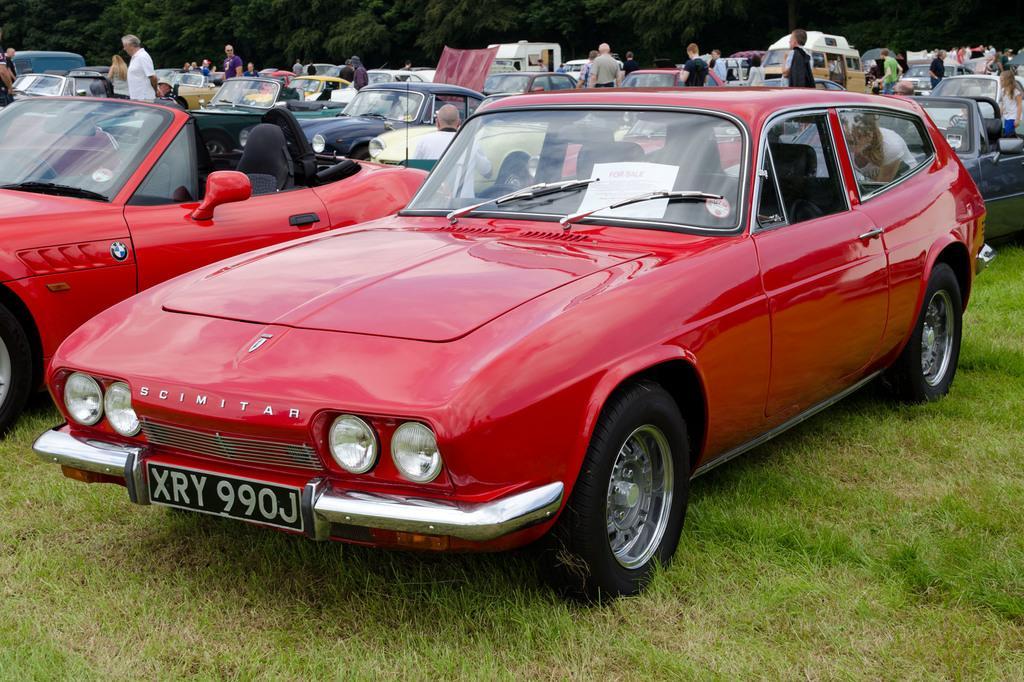Could you give a brief overview of what you see in this image? This image consists of many cars. In the front, there are two cars in red color. At the bottom, there is green grass on the ground. And we can see many people in this image. In the background, there are trees. 